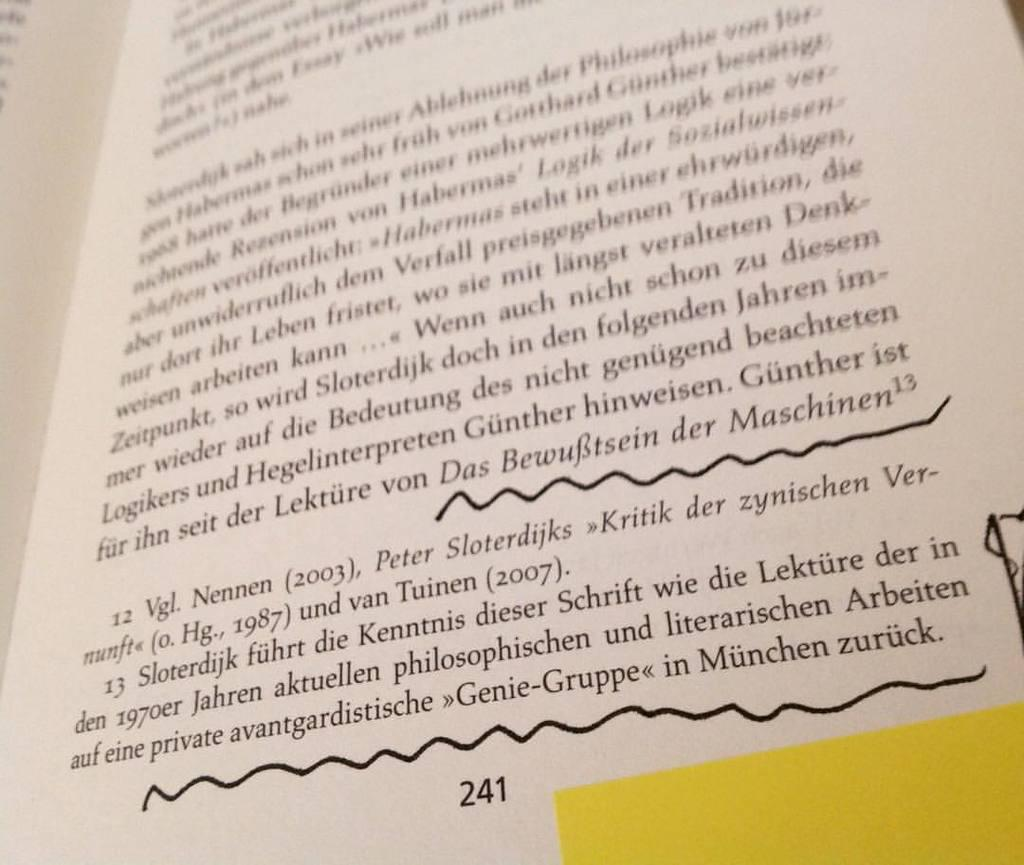<image>
Summarize the visual content of the image. Open book with writing on it on page 241. 